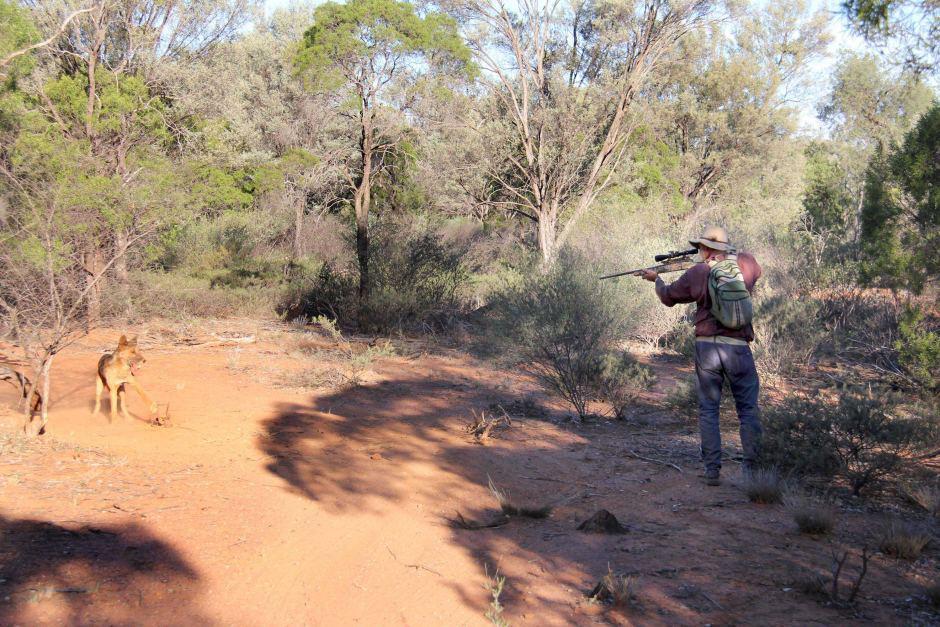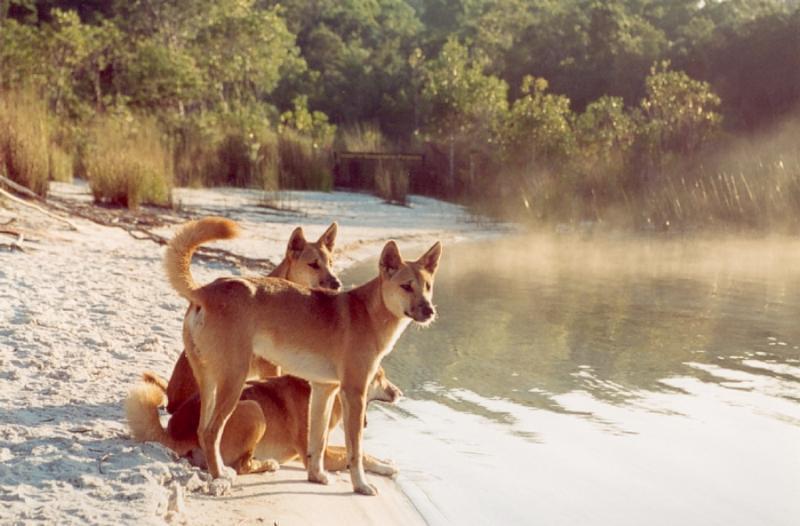The first image is the image on the left, the second image is the image on the right. Evaluate the accuracy of this statement regarding the images: "The dogs in one of the images are near a natural body of water.". Is it true? Answer yes or no. Yes. The first image is the image on the left, the second image is the image on the right. For the images shown, is this caption "Multiple dingos are at the edge of a body of water in one image." true? Answer yes or no. Yes. 